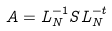Convert formula to latex. <formula><loc_0><loc_0><loc_500><loc_500>A = L _ { N } ^ { - 1 } S L _ { N } ^ { - t }</formula> 